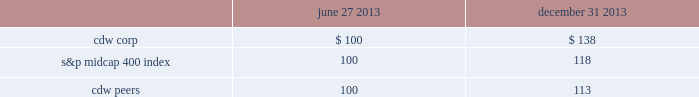
Use of proceeds from registered securities on july 2 , 2013 , the company completed an ipo of its common stock in which it issued and sold 23250000 shares of common stock .
On july 31 , 2013 , the company completed the sale of an additional 3487500 shares of common stock to the underwriters of the ipo pursuant to the underwriters 2019 july 26 , 2013 exercise in full of the overallotment option granted to them in connection with the ipo .
Such shares were registered under the securities act of 1933 , as amended , pursuant to the company 2019s registration statement on form s-1 ( file 333-187472 ) , which was declared effective by the sec on june 26 , 2013 .
The shares of common stock are listed on the nasdaq global select market under the symbol 201ccdw . 201d the company 2019s shares of common stock were sold to the underwriters at a price of $ 17.00 per share in the ipo and upon the exercise of the overallotment option , which together , generated aggregate net proceeds of $ 424.7 million to the company after deducting $ 29.8 million in underwriting discounts , expenses and transaction costs .
Using a portion of the net proceeds from the ipo ( exclusive of proceeds from the exercise of the overallotment option ) , the company paid a $ 24.4 million termination fee to affiliates of madison dearborn partners , llc and providence equity partners , l.l.c .
In connection with the termination of the management services agreement with such entities that was effective upon completion of the ipo , redeemed $ 175.0 million aggregate principal amount of senior secured notes due 2018 , and redeemed $ 146.0 million aggregate principal amount of senior subordinated notes due 2017 .
The redemption price of the senior secured notes due 2018 was 108.0% ( 108.0 % ) of the principal amount redeemed , plus accrued and unpaid interest to the date of redemption .
The company used cash on hand to pay such accrued and unpaid interest .
The redemption price of the senior subordinated notes due 2017 was 106.268% ( 106.268 % ) of the principal amount redeemed , plus accrued and unpaid interest to the date of redemption .
The company used cash on hand to pay such accrued and unpaid interest .
On october 18 , 2013 , proceeds from the overallotment option exercise of $ 56.0 million and cash on hand were used to redeem $ 155.0 million aggregate principal amount of senior subordinated notes due 2017 .
The redemption price of the senior subordinated notes due 2017 was 104.178% ( 104.178 % ) of the principal amount redeemed , plus accrued and unpaid interest to the date of redemption .
The company used cash on hand to pay such redemption premium and accrued and unpaid interest .
J.p .
Morgan securities llc , barclays capital inc .
And goldman , sachs & co .
Acted as joint book-running managers of the ipo and as representatives of the underwriters .
Deutsche bank securities inc .
And morgan stanley & co .
Llc acted as additional book-running managers in the ipo .
Robert w .
Baird & co .
Incorporated , raymond james & associates , inc. , william blair & company , l.l.c. , needham & company , llc , stifel , nicolaus & company , incorporated , loop capital markets llc and the williams capital group , l.p .
Acted as managing underwriters in the ipo. .
What were total generated aggregate proceeds to the company prior to deducting underwriting discounts , expenses and transaction costs , in millions? 
Computations: (424.7 + 29.8)
Answer: 454.5. 